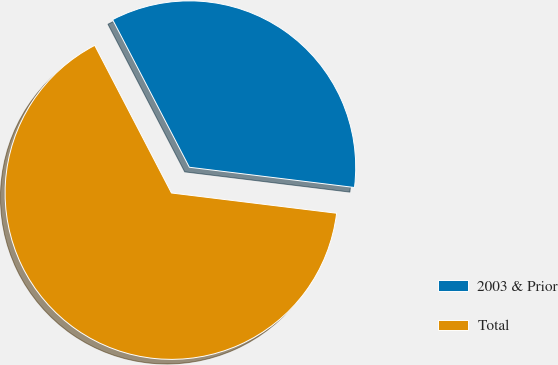<chart> <loc_0><loc_0><loc_500><loc_500><pie_chart><fcel>2003 & Prior<fcel>Total<nl><fcel>34.57%<fcel>65.43%<nl></chart> 